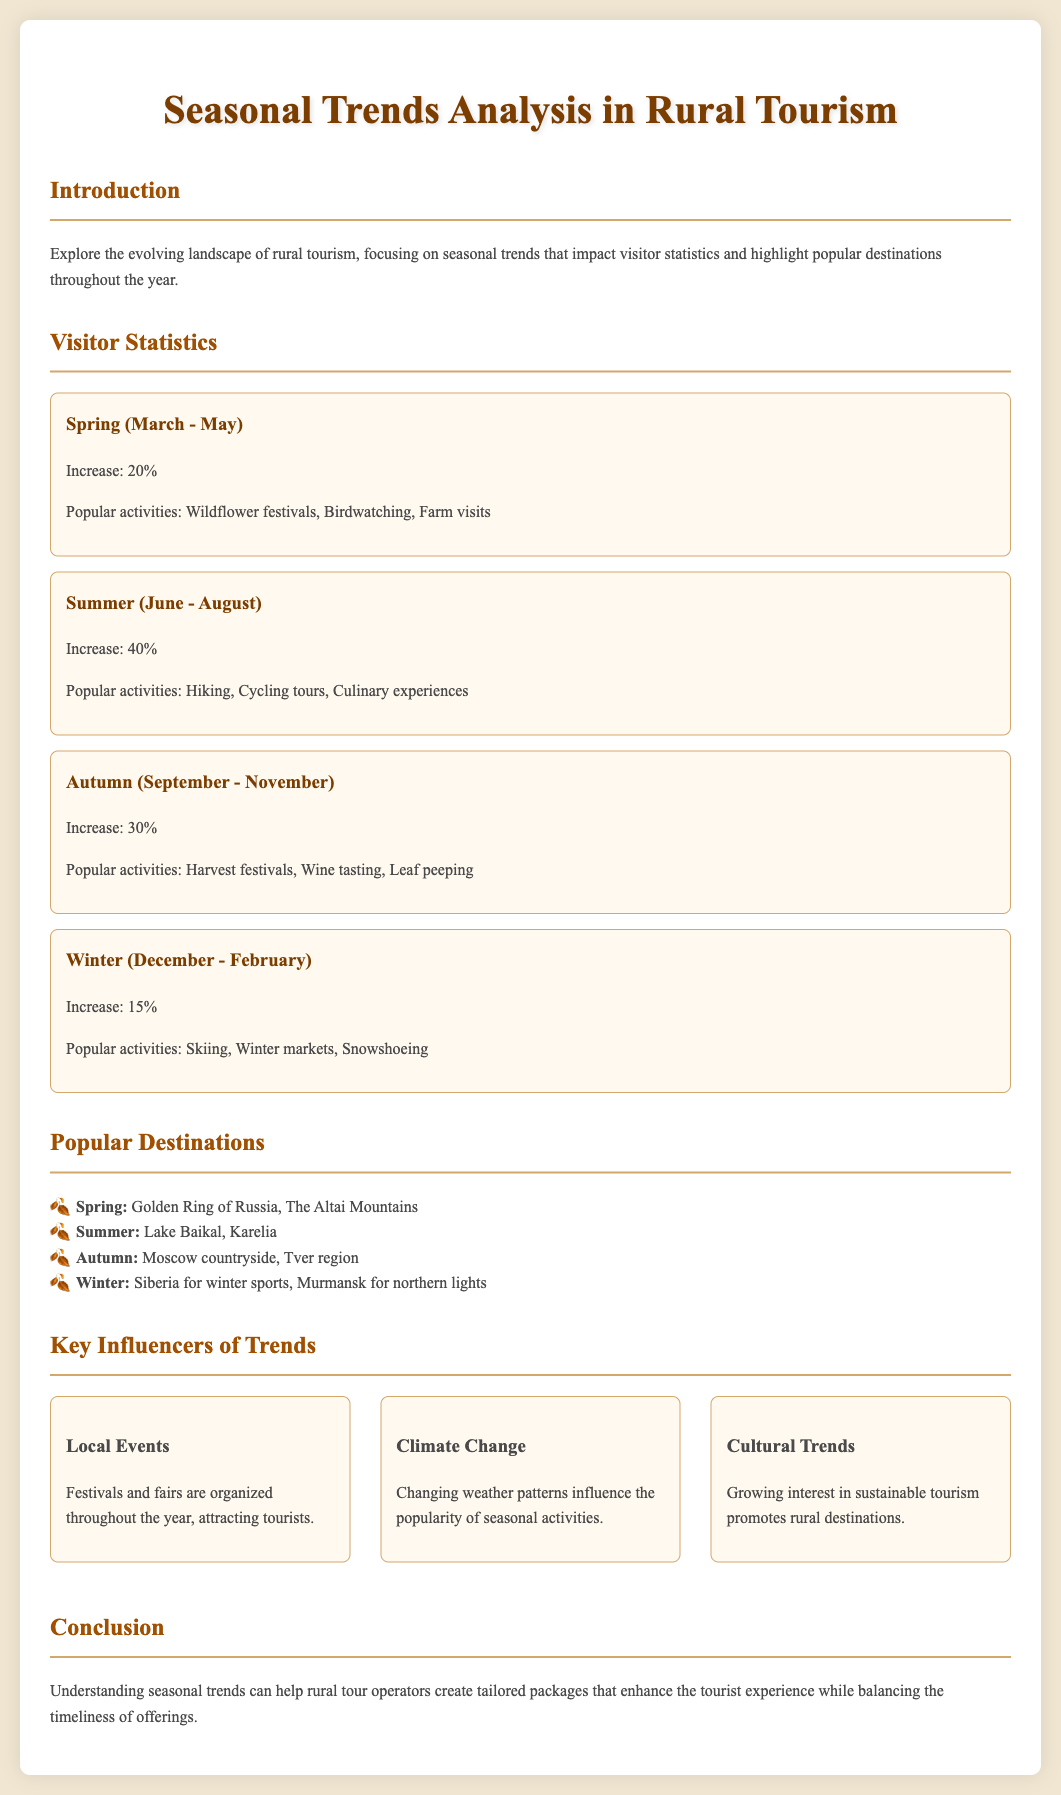What is the increase in visitor statistics during Spring? The document states that there is a 20% increase in visitor statistics during Spring.
Answer: 20% What popular activity is associated with Summer? The document mentions Hiking as one of the popular activities in Summer.
Answer: Hiking Which region is suggested for Autumn visits? According to the document, the Tver region is a popular destination for Autumn.
Answer: Tver region What is a key influencer of trends mentioned in the document? The document lists Local Events as one of the key influencers of trends in rural tourism.
Answer: Local Events What percentage increase in visitors is observed in Summer? The document specifies a 40% increase in visitors during Summer.
Answer: 40% Which season features Wine tasting as a popular activity? The document indicates that Wine tasting is a popular activity in Autumn.
Answer: Autumn What destination is highlighted for Winter activities? The document highlights Siberia for winter sports as a destination in Winter.
Answer: Siberia What is the main focus of this analysis? The main focus is on seasonal trends that impact visitor statistics in rural tourism.
Answer: Seasonal trends Which two destinations are popular in Spring? The document states that the Golden Ring of Russia and The Altai Mountains are popular in Spring.
Answer: Golden Ring of Russia, The Altai Mountains 